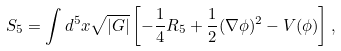Convert formula to latex. <formula><loc_0><loc_0><loc_500><loc_500>S _ { 5 } = \int d ^ { 5 } x \sqrt { | G | } \left [ - \frac { 1 } { 4 } R _ { 5 } + \frac { 1 } { 2 } ( \nabla \phi ) ^ { 2 } - V ( \phi ) \right ] ,</formula> 